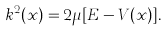Convert formula to latex. <formula><loc_0><loc_0><loc_500><loc_500>k ^ { 2 } ( x ) = 2 \mu [ E - V ( x ) ] .</formula> 